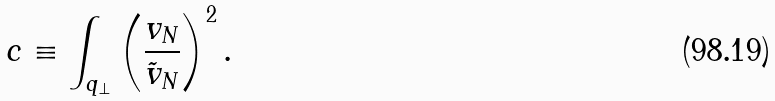Convert formula to latex. <formula><loc_0><loc_0><loc_500><loc_500>c \equiv \int _ { q _ { \perp } } \left ( \frac { v _ { N } } { \tilde { v } _ { N } } \right ) ^ { 2 } .</formula> 